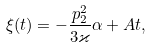<formula> <loc_0><loc_0><loc_500><loc_500>\xi ( t ) = - \frac { p _ { 2 } ^ { 2 } } { 3 \varkappa } \alpha + A t ,</formula> 